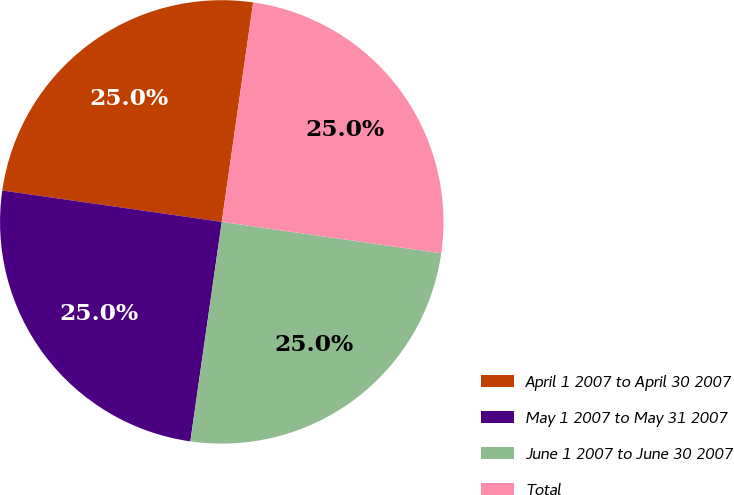<chart> <loc_0><loc_0><loc_500><loc_500><pie_chart><fcel>April 1 2007 to April 30 2007<fcel>May 1 2007 to May 31 2007<fcel>June 1 2007 to June 30 2007<fcel>Total<nl><fcel>25.0%<fcel>25.0%<fcel>25.0%<fcel>25.0%<nl></chart> 